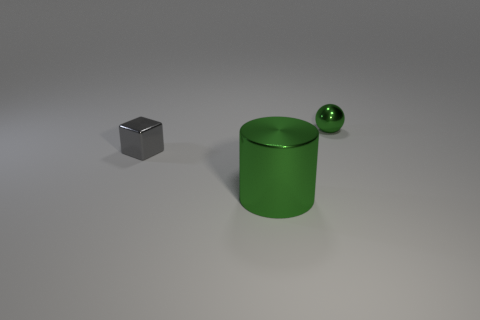Add 1 tiny green shiny objects. How many objects exist? 4 Subtract 1 cubes. How many cubes are left? 0 Add 1 large green metal cylinders. How many large green metal cylinders are left? 2 Add 2 tiny metal spheres. How many tiny metal spheres exist? 3 Subtract 0 blue cylinders. How many objects are left? 3 Subtract all cylinders. How many objects are left? 2 Subtract all brown balls. Subtract all yellow cylinders. How many balls are left? 1 Subtract all small blue metallic balls. Subtract all gray metal things. How many objects are left? 2 